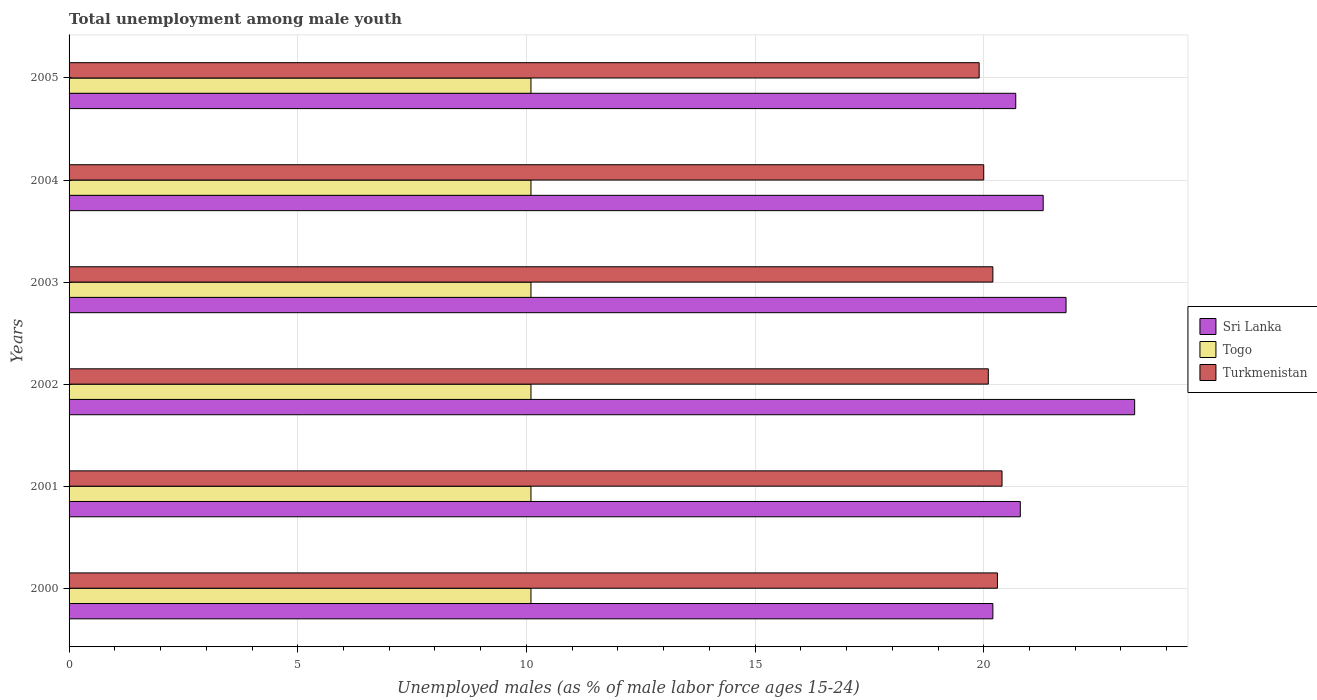How many groups of bars are there?
Keep it short and to the point. 6. How many bars are there on the 2nd tick from the bottom?
Offer a very short reply. 3. What is the label of the 1st group of bars from the top?
Make the answer very short. 2005. In how many cases, is the number of bars for a given year not equal to the number of legend labels?
Provide a short and direct response. 0. What is the percentage of unemployed males in in Sri Lanka in 2001?
Provide a short and direct response. 20.8. Across all years, what is the maximum percentage of unemployed males in in Togo?
Give a very brief answer. 10.1. Across all years, what is the minimum percentage of unemployed males in in Turkmenistan?
Make the answer very short. 19.9. In which year was the percentage of unemployed males in in Turkmenistan minimum?
Your answer should be very brief. 2005. What is the total percentage of unemployed males in in Sri Lanka in the graph?
Your answer should be very brief. 128.1. What is the difference between the percentage of unemployed males in in Turkmenistan in 2002 and that in 2003?
Offer a very short reply. -0.1. What is the difference between the percentage of unemployed males in in Togo in 2005 and the percentage of unemployed males in in Turkmenistan in 2000?
Offer a terse response. -10.2. What is the average percentage of unemployed males in in Togo per year?
Offer a very short reply. 10.1. In the year 2003, what is the difference between the percentage of unemployed males in in Turkmenistan and percentage of unemployed males in in Togo?
Your answer should be compact. 10.1. In how many years, is the percentage of unemployed males in in Sri Lanka greater than 19 %?
Your answer should be very brief. 6. What is the ratio of the percentage of unemployed males in in Sri Lanka in 2002 to that in 2005?
Offer a terse response. 1.13. Is the percentage of unemployed males in in Turkmenistan in 2002 less than that in 2005?
Provide a short and direct response. No. Is the difference between the percentage of unemployed males in in Turkmenistan in 2003 and 2004 greater than the difference between the percentage of unemployed males in in Togo in 2003 and 2004?
Provide a succinct answer. Yes. What is the difference between the highest and the second highest percentage of unemployed males in in Turkmenistan?
Make the answer very short. 0.1. Is the sum of the percentage of unemployed males in in Turkmenistan in 2000 and 2002 greater than the maximum percentage of unemployed males in in Togo across all years?
Provide a short and direct response. Yes. What does the 1st bar from the top in 2001 represents?
Offer a terse response. Turkmenistan. What does the 1st bar from the bottom in 2005 represents?
Give a very brief answer. Sri Lanka. Is it the case that in every year, the sum of the percentage of unemployed males in in Sri Lanka and percentage of unemployed males in in Togo is greater than the percentage of unemployed males in in Turkmenistan?
Make the answer very short. Yes. How many bars are there?
Offer a very short reply. 18. How many years are there in the graph?
Keep it short and to the point. 6. What is the difference between two consecutive major ticks on the X-axis?
Your response must be concise. 5. Does the graph contain any zero values?
Provide a succinct answer. No. Does the graph contain grids?
Your answer should be compact. Yes. Where does the legend appear in the graph?
Give a very brief answer. Center right. How many legend labels are there?
Your answer should be compact. 3. What is the title of the graph?
Offer a very short reply. Total unemployment among male youth. Does "Italy" appear as one of the legend labels in the graph?
Make the answer very short. No. What is the label or title of the X-axis?
Make the answer very short. Unemployed males (as % of male labor force ages 15-24). What is the Unemployed males (as % of male labor force ages 15-24) of Sri Lanka in 2000?
Provide a succinct answer. 20.2. What is the Unemployed males (as % of male labor force ages 15-24) in Togo in 2000?
Your answer should be very brief. 10.1. What is the Unemployed males (as % of male labor force ages 15-24) of Turkmenistan in 2000?
Provide a succinct answer. 20.3. What is the Unemployed males (as % of male labor force ages 15-24) of Sri Lanka in 2001?
Your response must be concise. 20.8. What is the Unemployed males (as % of male labor force ages 15-24) in Togo in 2001?
Your response must be concise. 10.1. What is the Unemployed males (as % of male labor force ages 15-24) in Turkmenistan in 2001?
Provide a succinct answer. 20.4. What is the Unemployed males (as % of male labor force ages 15-24) of Sri Lanka in 2002?
Ensure brevity in your answer.  23.3. What is the Unemployed males (as % of male labor force ages 15-24) in Togo in 2002?
Make the answer very short. 10.1. What is the Unemployed males (as % of male labor force ages 15-24) in Turkmenistan in 2002?
Keep it short and to the point. 20.1. What is the Unemployed males (as % of male labor force ages 15-24) of Sri Lanka in 2003?
Make the answer very short. 21.8. What is the Unemployed males (as % of male labor force ages 15-24) in Togo in 2003?
Offer a very short reply. 10.1. What is the Unemployed males (as % of male labor force ages 15-24) of Turkmenistan in 2003?
Make the answer very short. 20.2. What is the Unemployed males (as % of male labor force ages 15-24) in Sri Lanka in 2004?
Provide a short and direct response. 21.3. What is the Unemployed males (as % of male labor force ages 15-24) of Togo in 2004?
Make the answer very short. 10.1. What is the Unemployed males (as % of male labor force ages 15-24) of Turkmenistan in 2004?
Offer a very short reply. 20. What is the Unemployed males (as % of male labor force ages 15-24) of Sri Lanka in 2005?
Make the answer very short. 20.7. What is the Unemployed males (as % of male labor force ages 15-24) of Togo in 2005?
Keep it short and to the point. 10.1. What is the Unemployed males (as % of male labor force ages 15-24) of Turkmenistan in 2005?
Provide a short and direct response. 19.9. Across all years, what is the maximum Unemployed males (as % of male labor force ages 15-24) of Sri Lanka?
Your answer should be very brief. 23.3. Across all years, what is the maximum Unemployed males (as % of male labor force ages 15-24) in Togo?
Make the answer very short. 10.1. Across all years, what is the maximum Unemployed males (as % of male labor force ages 15-24) in Turkmenistan?
Ensure brevity in your answer.  20.4. Across all years, what is the minimum Unemployed males (as % of male labor force ages 15-24) in Sri Lanka?
Your answer should be compact. 20.2. Across all years, what is the minimum Unemployed males (as % of male labor force ages 15-24) of Togo?
Your answer should be very brief. 10.1. Across all years, what is the minimum Unemployed males (as % of male labor force ages 15-24) of Turkmenistan?
Your answer should be compact. 19.9. What is the total Unemployed males (as % of male labor force ages 15-24) of Sri Lanka in the graph?
Your response must be concise. 128.1. What is the total Unemployed males (as % of male labor force ages 15-24) of Togo in the graph?
Your answer should be compact. 60.6. What is the total Unemployed males (as % of male labor force ages 15-24) in Turkmenistan in the graph?
Your answer should be very brief. 120.9. What is the difference between the Unemployed males (as % of male labor force ages 15-24) in Togo in 2000 and that in 2001?
Your answer should be very brief. 0. What is the difference between the Unemployed males (as % of male labor force ages 15-24) of Turkmenistan in 2000 and that in 2001?
Make the answer very short. -0.1. What is the difference between the Unemployed males (as % of male labor force ages 15-24) in Turkmenistan in 2000 and that in 2003?
Make the answer very short. 0.1. What is the difference between the Unemployed males (as % of male labor force ages 15-24) in Sri Lanka in 2000 and that in 2004?
Give a very brief answer. -1.1. What is the difference between the Unemployed males (as % of male labor force ages 15-24) in Togo in 2000 and that in 2004?
Ensure brevity in your answer.  0. What is the difference between the Unemployed males (as % of male labor force ages 15-24) of Turkmenistan in 2000 and that in 2004?
Provide a succinct answer. 0.3. What is the difference between the Unemployed males (as % of male labor force ages 15-24) of Sri Lanka in 2000 and that in 2005?
Ensure brevity in your answer.  -0.5. What is the difference between the Unemployed males (as % of male labor force ages 15-24) of Turkmenistan in 2000 and that in 2005?
Your answer should be compact. 0.4. What is the difference between the Unemployed males (as % of male labor force ages 15-24) in Togo in 2001 and that in 2002?
Offer a very short reply. 0. What is the difference between the Unemployed males (as % of male labor force ages 15-24) of Turkmenistan in 2001 and that in 2002?
Provide a succinct answer. 0.3. What is the difference between the Unemployed males (as % of male labor force ages 15-24) of Sri Lanka in 2001 and that in 2003?
Your answer should be very brief. -1. What is the difference between the Unemployed males (as % of male labor force ages 15-24) of Togo in 2001 and that in 2003?
Your answer should be very brief. 0. What is the difference between the Unemployed males (as % of male labor force ages 15-24) in Turkmenistan in 2001 and that in 2003?
Provide a short and direct response. 0.2. What is the difference between the Unemployed males (as % of male labor force ages 15-24) of Togo in 2001 and that in 2004?
Give a very brief answer. 0. What is the difference between the Unemployed males (as % of male labor force ages 15-24) of Sri Lanka in 2002 and that in 2003?
Give a very brief answer. 1.5. What is the difference between the Unemployed males (as % of male labor force ages 15-24) in Turkmenistan in 2002 and that in 2003?
Keep it short and to the point. -0.1. What is the difference between the Unemployed males (as % of male labor force ages 15-24) in Sri Lanka in 2002 and that in 2004?
Provide a short and direct response. 2. What is the difference between the Unemployed males (as % of male labor force ages 15-24) of Turkmenistan in 2002 and that in 2004?
Your answer should be very brief. 0.1. What is the difference between the Unemployed males (as % of male labor force ages 15-24) of Turkmenistan in 2002 and that in 2005?
Make the answer very short. 0.2. What is the difference between the Unemployed males (as % of male labor force ages 15-24) in Togo in 2003 and that in 2004?
Provide a short and direct response. 0. What is the difference between the Unemployed males (as % of male labor force ages 15-24) of Turkmenistan in 2003 and that in 2004?
Offer a terse response. 0.2. What is the difference between the Unemployed males (as % of male labor force ages 15-24) of Sri Lanka in 2003 and that in 2005?
Keep it short and to the point. 1.1. What is the difference between the Unemployed males (as % of male labor force ages 15-24) of Turkmenistan in 2003 and that in 2005?
Your answer should be compact. 0.3. What is the difference between the Unemployed males (as % of male labor force ages 15-24) of Sri Lanka in 2000 and the Unemployed males (as % of male labor force ages 15-24) of Turkmenistan in 2001?
Give a very brief answer. -0.2. What is the difference between the Unemployed males (as % of male labor force ages 15-24) of Sri Lanka in 2000 and the Unemployed males (as % of male labor force ages 15-24) of Turkmenistan in 2002?
Keep it short and to the point. 0.1. What is the difference between the Unemployed males (as % of male labor force ages 15-24) in Togo in 2000 and the Unemployed males (as % of male labor force ages 15-24) in Turkmenistan in 2002?
Your answer should be very brief. -10. What is the difference between the Unemployed males (as % of male labor force ages 15-24) in Sri Lanka in 2000 and the Unemployed males (as % of male labor force ages 15-24) in Turkmenistan in 2003?
Offer a terse response. 0. What is the difference between the Unemployed males (as % of male labor force ages 15-24) of Sri Lanka in 2000 and the Unemployed males (as % of male labor force ages 15-24) of Togo in 2004?
Your answer should be very brief. 10.1. What is the difference between the Unemployed males (as % of male labor force ages 15-24) in Sri Lanka in 2000 and the Unemployed males (as % of male labor force ages 15-24) in Turkmenistan in 2004?
Ensure brevity in your answer.  0.2. What is the difference between the Unemployed males (as % of male labor force ages 15-24) in Sri Lanka in 2000 and the Unemployed males (as % of male labor force ages 15-24) in Togo in 2005?
Ensure brevity in your answer.  10.1. What is the difference between the Unemployed males (as % of male labor force ages 15-24) in Sri Lanka in 2000 and the Unemployed males (as % of male labor force ages 15-24) in Turkmenistan in 2005?
Your answer should be compact. 0.3. What is the difference between the Unemployed males (as % of male labor force ages 15-24) of Togo in 2001 and the Unemployed males (as % of male labor force ages 15-24) of Turkmenistan in 2003?
Provide a succinct answer. -10.1. What is the difference between the Unemployed males (as % of male labor force ages 15-24) in Sri Lanka in 2001 and the Unemployed males (as % of male labor force ages 15-24) in Togo in 2004?
Keep it short and to the point. 10.7. What is the difference between the Unemployed males (as % of male labor force ages 15-24) in Sri Lanka in 2001 and the Unemployed males (as % of male labor force ages 15-24) in Togo in 2005?
Offer a very short reply. 10.7. What is the difference between the Unemployed males (as % of male labor force ages 15-24) in Sri Lanka in 2001 and the Unemployed males (as % of male labor force ages 15-24) in Turkmenistan in 2005?
Make the answer very short. 0.9. What is the difference between the Unemployed males (as % of male labor force ages 15-24) of Togo in 2001 and the Unemployed males (as % of male labor force ages 15-24) of Turkmenistan in 2005?
Provide a succinct answer. -9.8. What is the difference between the Unemployed males (as % of male labor force ages 15-24) of Sri Lanka in 2002 and the Unemployed males (as % of male labor force ages 15-24) of Togo in 2003?
Your answer should be compact. 13.2. What is the difference between the Unemployed males (as % of male labor force ages 15-24) in Sri Lanka in 2002 and the Unemployed males (as % of male labor force ages 15-24) in Togo in 2004?
Keep it short and to the point. 13.2. What is the difference between the Unemployed males (as % of male labor force ages 15-24) in Sri Lanka in 2002 and the Unemployed males (as % of male labor force ages 15-24) in Turkmenistan in 2004?
Your answer should be compact. 3.3. What is the difference between the Unemployed males (as % of male labor force ages 15-24) of Togo in 2002 and the Unemployed males (as % of male labor force ages 15-24) of Turkmenistan in 2004?
Make the answer very short. -9.9. What is the difference between the Unemployed males (as % of male labor force ages 15-24) in Sri Lanka in 2002 and the Unemployed males (as % of male labor force ages 15-24) in Turkmenistan in 2005?
Make the answer very short. 3.4. What is the difference between the Unemployed males (as % of male labor force ages 15-24) in Sri Lanka in 2003 and the Unemployed males (as % of male labor force ages 15-24) in Togo in 2004?
Your answer should be compact. 11.7. What is the difference between the Unemployed males (as % of male labor force ages 15-24) of Sri Lanka in 2003 and the Unemployed males (as % of male labor force ages 15-24) of Turkmenistan in 2004?
Provide a succinct answer. 1.8. What is the difference between the Unemployed males (as % of male labor force ages 15-24) in Togo in 2003 and the Unemployed males (as % of male labor force ages 15-24) in Turkmenistan in 2004?
Give a very brief answer. -9.9. What is the difference between the Unemployed males (as % of male labor force ages 15-24) of Sri Lanka in 2003 and the Unemployed males (as % of male labor force ages 15-24) of Turkmenistan in 2005?
Your answer should be compact. 1.9. What is the difference between the Unemployed males (as % of male labor force ages 15-24) of Sri Lanka in 2004 and the Unemployed males (as % of male labor force ages 15-24) of Turkmenistan in 2005?
Provide a short and direct response. 1.4. What is the difference between the Unemployed males (as % of male labor force ages 15-24) of Togo in 2004 and the Unemployed males (as % of male labor force ages 15-24) of Turkmenistan in 2005?
Your response must be concise. -9.8. What is the average Unemployed males (as % of male labor force ages 15-24) of Sri Lanka per year?
Make the answer very short. 21.35. What is the average Unemployed males (as % of male labor force ages 15-24) in Turkmenistan per year?
Your answer should be very brief. 20.15. In the year 2000, what is the difference between the Unemployed males (as % of male labor force ages 15-24) in Sri Lanka and Unemployed males (as % of male labor force ages 15-24) in Togo?
Your answer should be compact. 10.1. In the year 2001, what is the difference between the Unemployed males (as % of male labor force ages 15-24) in Sri Lanka and Unemployed males (as % of male labor force ages 15-24) in Togo?
Your response must be concise. 10.7. In the year 2002, what is the difference between the Unemployed males (as % of male labor force ages 15-24) in Sri Lanka and Unemployed males (as % of male labor force ages 15-24) in Togo?
Your answer should be compact. 13.2. In the year 2002, what is the difference between the Unemployed males (as % of male labor force ages 15-24) of Sri Lanka and Unemployed males (as % of male labor force ages 15-24) of Turkmenistan?
Your answer should be very brief. 3.2. In the year 2002, what is the difference between the Unemployed males (as % of male labor force ages 15-24) of Togo and Unemployed males (as % of male labor force ages 15-24) of Turkmenistan?
Give a very brief answer. -10. In the year 2003, what is the difference between the Unemployed males (as % of male labor force ages 15-24) in Sri Lanka and Unemployed males (as % of male labor force ages 15-24) in Togo?
Make the answer very short. 11.7. In the year 2003, what is the difference between the Unemployed males (as % of male labor force ages 15-24) of Sri Lanka and Unemployed males (as % of male labor force ages 15-24) of Turkmenistan?
Your answer should be compact. 1.6. In the year 2004, what is the difference between the Unemployed males (as % of male labor force ages 15-24) of Sri Lanka and Unemployed males (as % of male labor force ages 15-24) of Togo?
Your answer should be compact. 11.2. In the year 2004, what is the difference between the Unemployed males (as % of male labor force ages 15-24) in Sri Lanka and Unemployed males (as % of male labor force ages 15-24) in Turkmenistan?
Your response must be concise. 1.3. In the year 2004, what is the difference between the Unemployed males (as % of male labor force ages 15-24) of Togo and Unemployed males (as % of male labor force ages 15-24) of Turkmenistan?
Your answer should be very brief. -9.9. In the year 2005, what is the difference between the Unemployed males (as % of male labor force ages 15-24) in Sri Lanka and Unemployed males (as % of male labor force ages 15-24) in Togo?
Your answer should be very brief. 10.6. In the year 2005, what is the difference between the Unemployed males (as % of male labor force ages 15-24) in Togo and Unemployed males (as % of male labor force ages 15-24) in Turkmenistan?
Your response must be concise. -9.8. What is the ratio of the Unemployed males (as % of male labor force ages 15-24) of Sri Lanka in 2000 to that in 2001?
Ensure brevity in your answer.  0.97. What is the ratio of the Unemployed males (as % of male labor force ages 15-24) in Sri Lanka in 2000 to that in 2002?
Offer a terse response. 0.87. What is the ratio of the Unemployed males (as % of male labor force ages 15-24) of Togo in 2000 to that in 2002?
Offer a terse response. 1. What is the ratio of the Unemployed males (as % of male labor force ages 15-24) of Turkmenistan in 2000 to that in 2002?
Your response must be concise. 1.01. What is the ratio of the Unemployed males (as % of male labor force ages 15-24) of Sri Lanka in 2000 to that in 2003?
Offer a very short reply. 0.93. What is the ratio of the Unemployed males (as % of male labor force ages 15-24) in Togo in 2000 to that in 2003?
Offer a terse response. 1. What is the ratio of the Unemployed males (as % of male labor force ages 15-24) of Turkmenistan in 2000 to that in 2003?
Provide a short and direct response. 1. What is the ratio of the Unemployed males (as % of male labor force ages 15-24) in Sri Lanka in 2000 to that in 2004?
Keep it short and to the point. 0.95. What is the ratio of the Unemployed males (as % of male labor force ages 15-24) of Togo in 2000 to that in 2004?
Give a very brief answer. 1. What is the ratio of the Unemployed males (as % of male labor force ages 15-24) in Turkmenistan in 2000 to that in 2004?
Your response must be concise. 1.01. What is the ratio of the Unemployed males (as % of male labor force ages 15-24) of Sri Lanka in 2000 to that in 2005?
Make the answer very short. 0.98. What is the ratio of the Unemployed males (as % of male labor force ages 15-24) in Togo in 2000 to that in 2005?
Your answer should be compact. 1. What is the ratio of the Unemployed males (as % of male labor force ages 15-24) of Turkmenistan in 2000 to that in 2005?
Give a very brief answer. 1.02. What is the ratio of the Unemployed males (as % of male labor force ages 15-24) of Sri Lanka in 2001 to that in 2002?
Ensure brevity in your answer.  0.89. What is the ratio of the Unemployed males (as % of male labor force ages 15-24) in Turkmenistan in 2001 to that in 2002?
Offer a very short reply. 1.01. What is the ratio of the Unemployed males (as % of male labor force ages 15-24) in Sri Lanka in 2001 to that in 2003?
Provide a short and direct response. 0.95. What is the ratio of the Unemployed males (as % of male labor force ages 15-24) of Turkmenistan in 2001 to that in 2003?
Your answer should be very brief. 1.01. What is the ratio of the Unemployed males (as % of male labor force ages 15-24) in Sri Lanka in 2001 to that in 2004?
Provide a succinct answer. 0.98. What is the ratio of the Unemployed males (as % of male labor force ages 15-24) in Togo in 2001 to that in 2004?
Offer a terse response. 1. What is the ratio of the Unemployed males (as % of male labor force ages 15-24) in Togo in 2001 to that in 2005?
Give a very brief answer. 1. What is the ratio of the Unemployed males (as % of male labor force ages 15-24) of Turkmenistan in 2001 to that in 2005?
Provide a short and direct response. 1.03. What is the ratio of the Unemployed males (as % of male labor force ages 15-24) of Sri Lanka in 2002 to that in 2003?
Offer a terse response. 1.07. What is the ratio of the Unemployed males (as % of male labor force ages 15-24) of Turkmenistan in 2002 to that in 2003?
Give a very brief answer. 0.99. What is the ratio of the Unemployed males (as % of male labor force ages 15-24) in Sri Lanka in 2002 to that in 2004?
Keep it short and to the point. 1.09. What is the ratio of the Unemployed males (as % of male labor force ages 15-24) in Turkmenistan in 2002 to that in 2004?
Ensure brevity in your answer.  1. What is the ratio of the Unemployed males (as % of male labor force ages 15-24) in Sri Lanka in 2002 to that in 2005?
Offer a very short reply. 1.13. What is the ratio of the Unemployed males (as % of male labor force ages 15-24) of Togo in 2002 to that in 2005?
Make the answer very short. 1. What is the ratio of the Unemployed males (as % of male labor force ages 15-24) of Turkmenistan in 2002 to that in 2005?
Make the answer very short. 1.01. What is the ratio of the Unemployed males (as % of male labor force ages 15-24) of Sri Lanka in 2003 to that in 2004?
Your answer should be compact. 1.02. What is the ratio of the Unemployed males (as % of male labor force ages 15-24) in Togo in 2003 to that in 2004?
Offer a terse response. 1. What is the ratio of the Unemployed males (as % of male labor force ages 15-24) in Sri Lanka in 2003 to that in 2005?
Your response must be concise. 1.05. What is the ratio of the Unemployed males (as % of male labor force ages 15-24) of Turkmenistan in 2003 to that in 2005?
Give a very brief answer. 1.02. What is the ratio of the Unemployed males (as % of male labor force ages 15-24) of Sri Lanka in 2004 to that in 2005?
Ensure brevity in your answer.  1.03. What is the difference between the highest and the second highest Unemployed males (as % of male labor force ages 15-24) in Sri Lanka?
Offer a very short reply. 1.5. What is the difference between the highest and the second highest Unemployed males (as % of male labor force ages 15-24) in Turkmenistan?
Your answer should be very brief. 0.1. What is the difference between the highest and the lowest Unemployed males (as % of male labor force ages 15-24) in Togo?
Offer a very short reply. 0. What is the difference between the highest and the lowest Unemployed males (as % of male labor force ages 15-24) in Turkmenistan?
Provide a succinct answer. 0.5. 